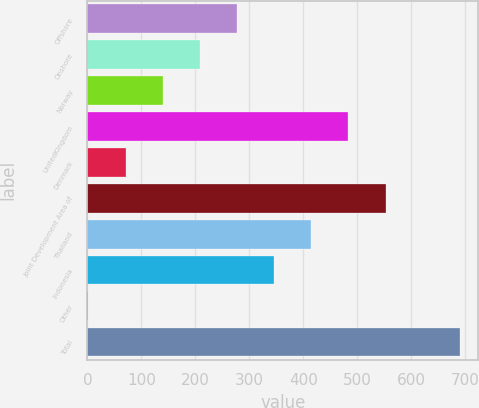Convert chart. <chart><loc_0><loc_0><loc_500><loc_500><bar_chart><fcel>Offshore<fcel>Onshore<fcel>Norway<fcel>UnitedKingdom<fcel>Denmark<fcel>Joint Development Area of<fcel>Thailand<fcel>Indonesia<fcel>Other<fcel>Total<nl><fcel>277.2<fcel>208.4<fcel>139.6<fcel>483.6<fcel>70.8<fcel>552.4<fcel>414.8<fcel>346<fcel>2<fcel>690<nl></chart> 